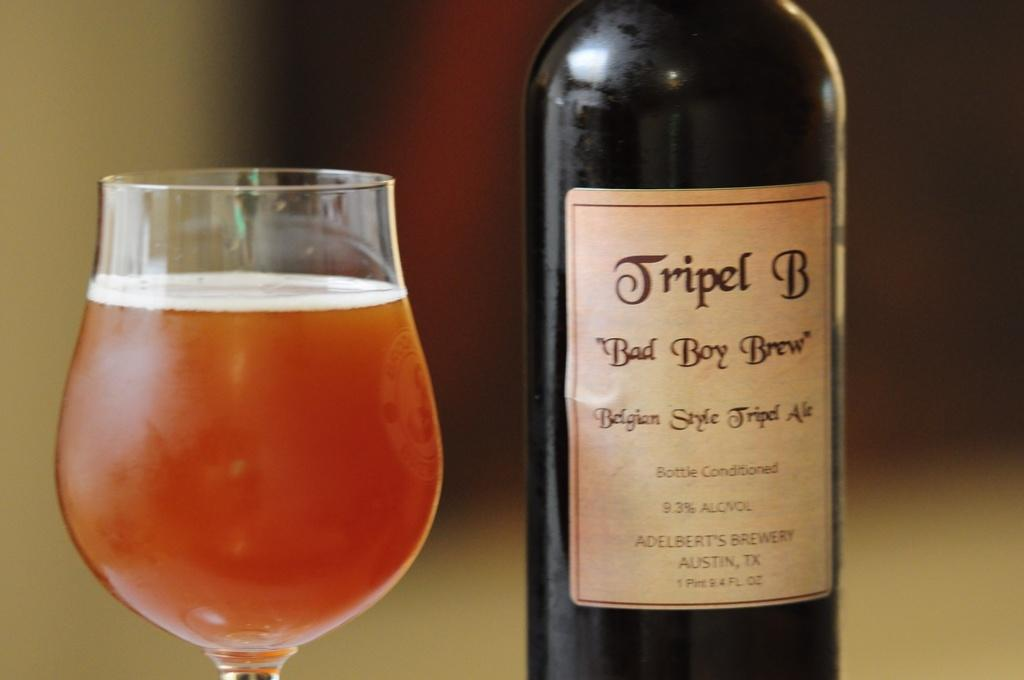Provide a one-sentence caption for the provided image. Tripel B Bad Boy Brew contains 9.3% ALC/VOL. 